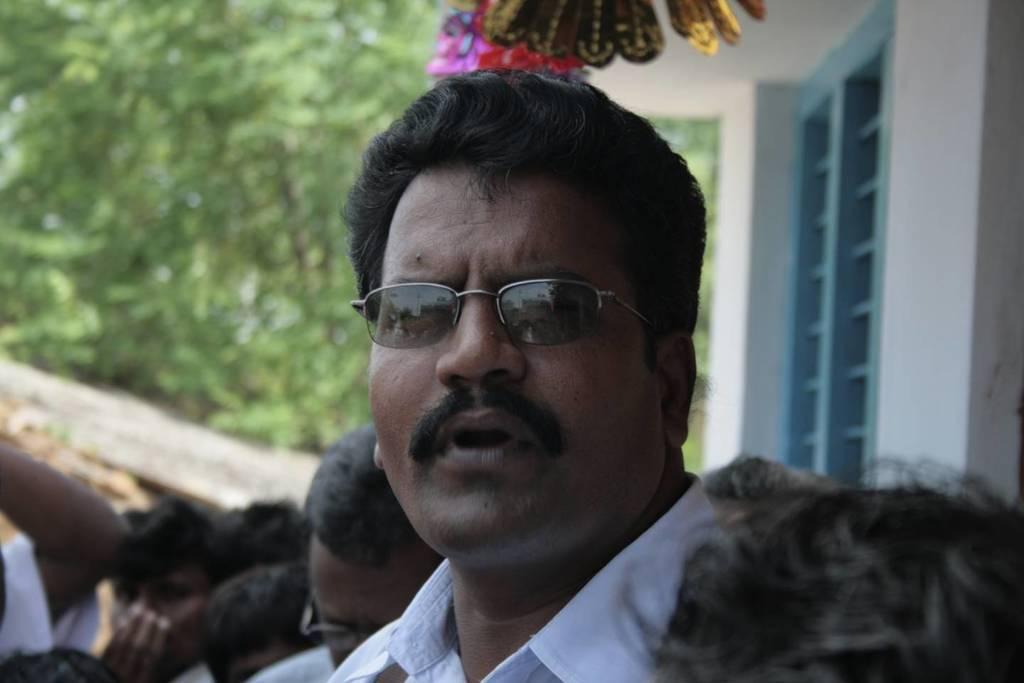How would you summarize this image in a sentence or two? In this image we can see a person wearing white shirt and spectacles is standing here. Here we can see a few more people standing. The background of the image is slightly blurred, where we can see a window to the wall and trees. 